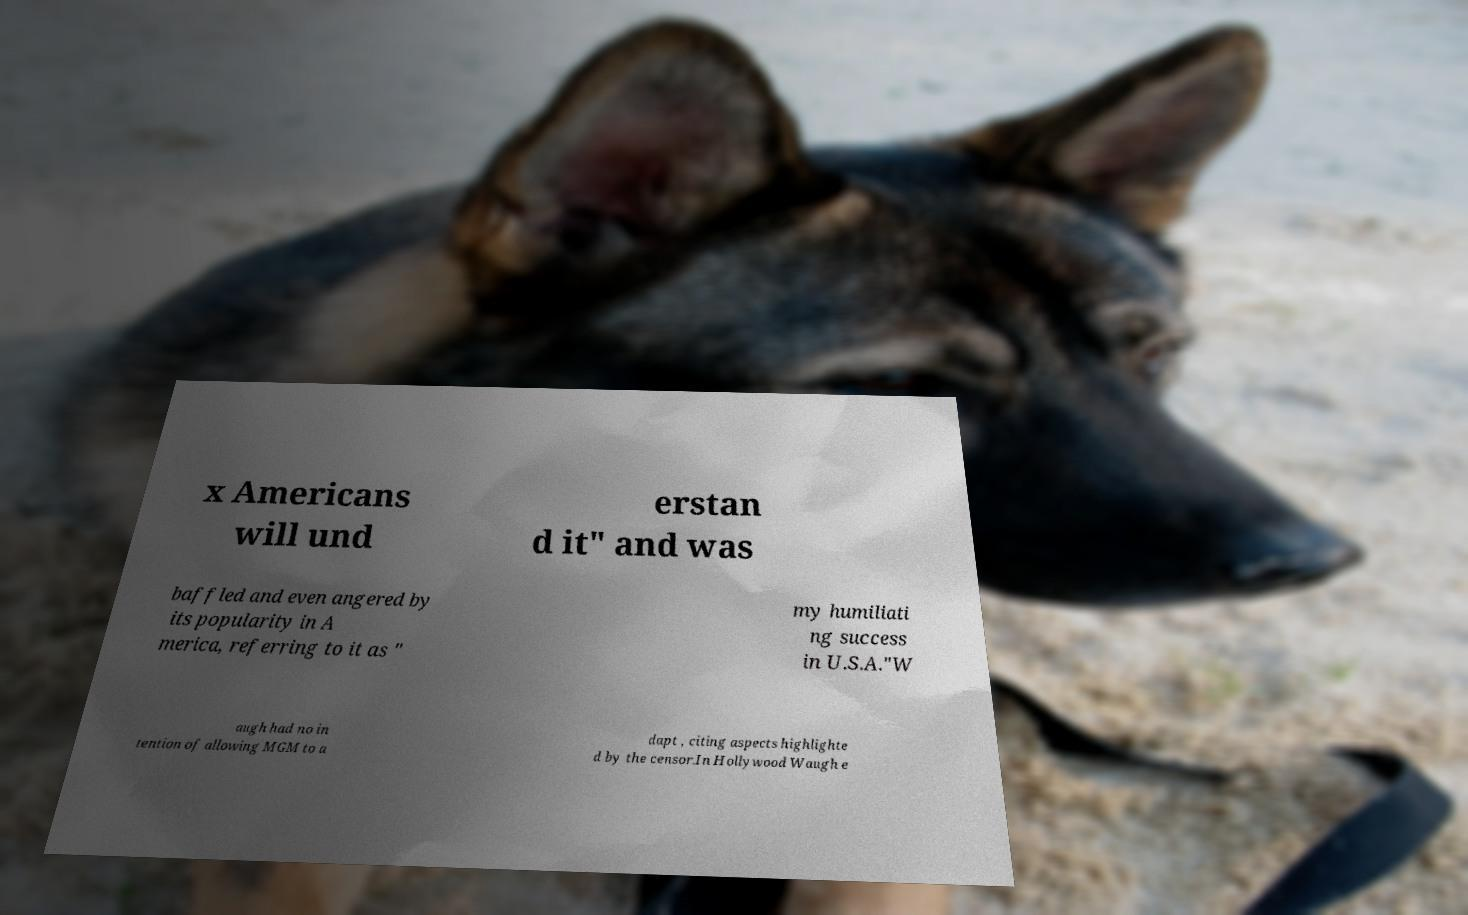Please read and relay the text visible in this image. What does it say? x Americans will und erstan d it" and was baffled and even angered by its popularity in A merica, referring to it as " my humiliati ng success in U.S.A."W augh had no in tention of allowing MGM to a dapt , citing aspects highlighte d by the censor.In Hollywood Waugh e 